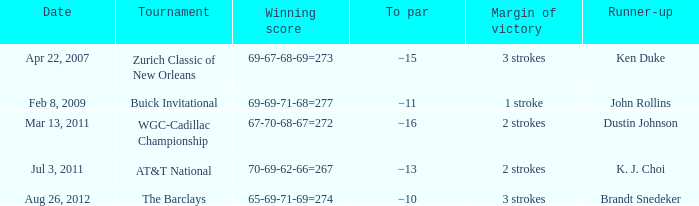What is the date that has a winning score of 67-70-68-67=272? Mar 13, 2011. 